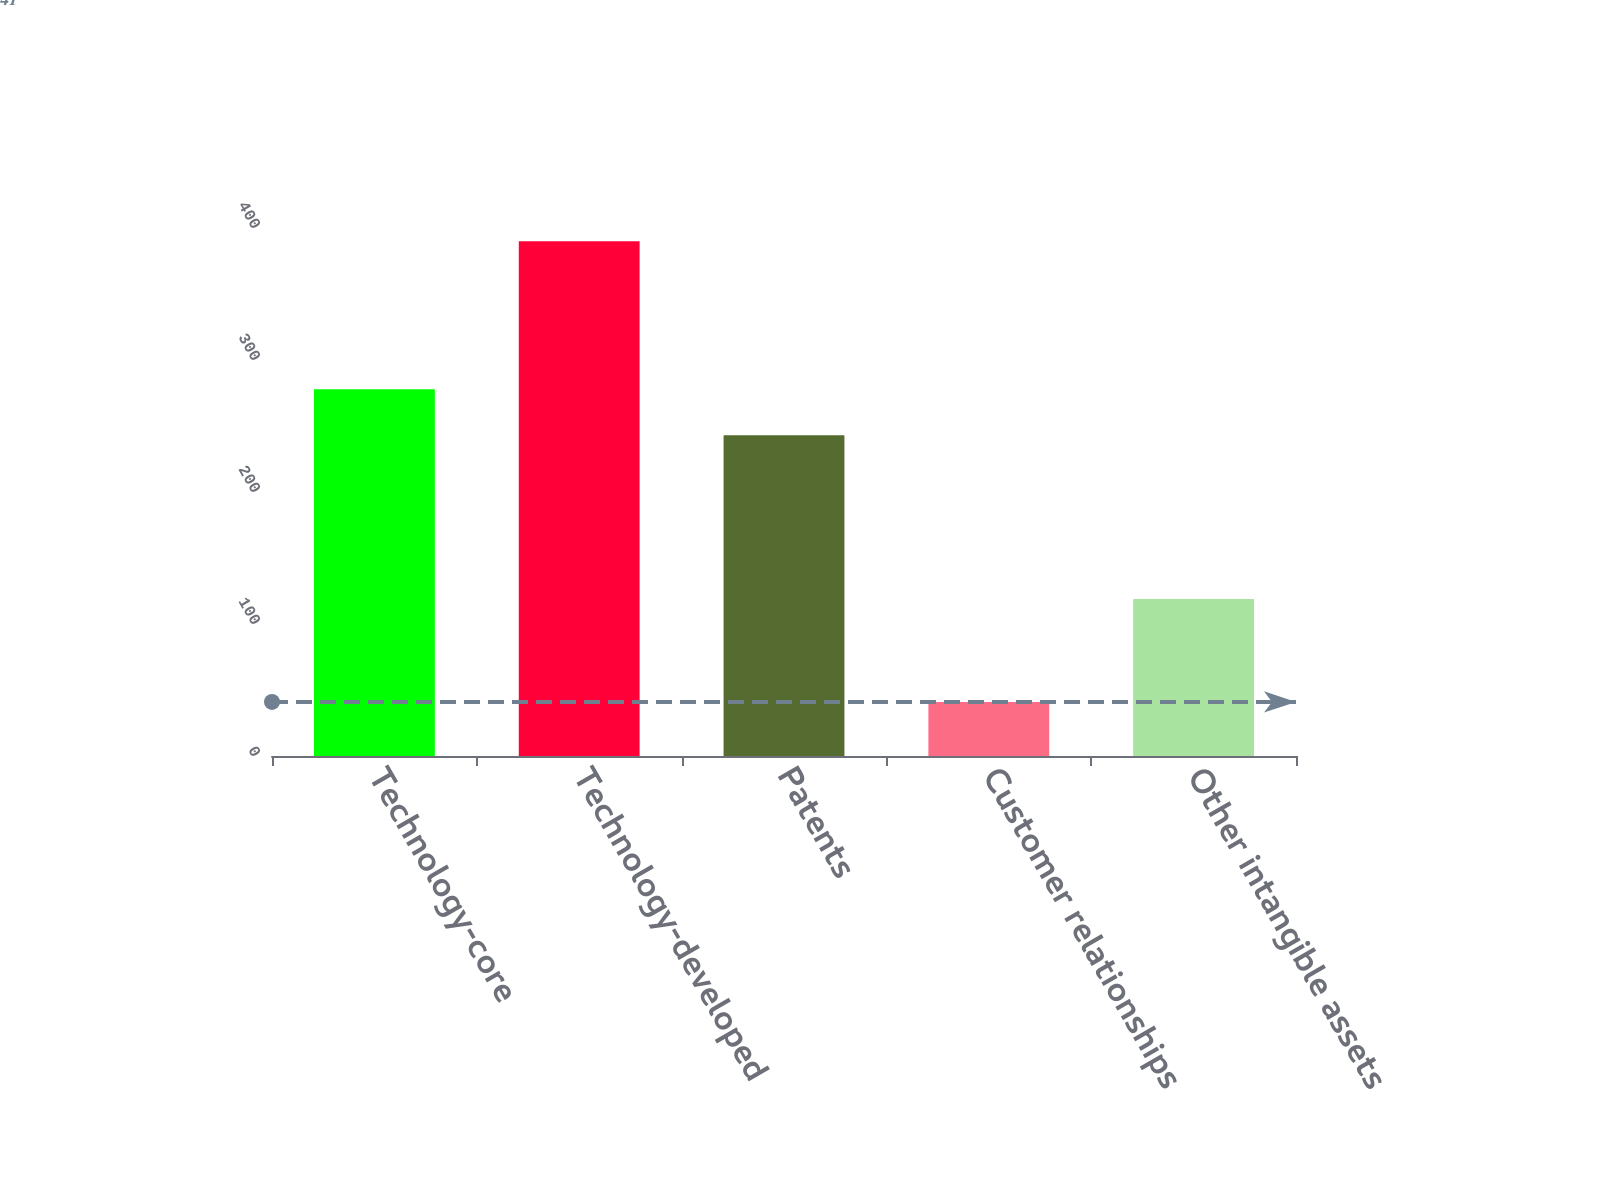Convert chart. <chart><loc_0><loc_0><loc_500><loc_500><bar_chart><fcel>Technology-core<fcel>Technology-developed<fcel>Patents<fcel>Customer relationships<fcel>Other intangible assets<nl><fcel>277.9<fcel>390<fcel>243<fcel>41<fcel>119<nl></chart> 